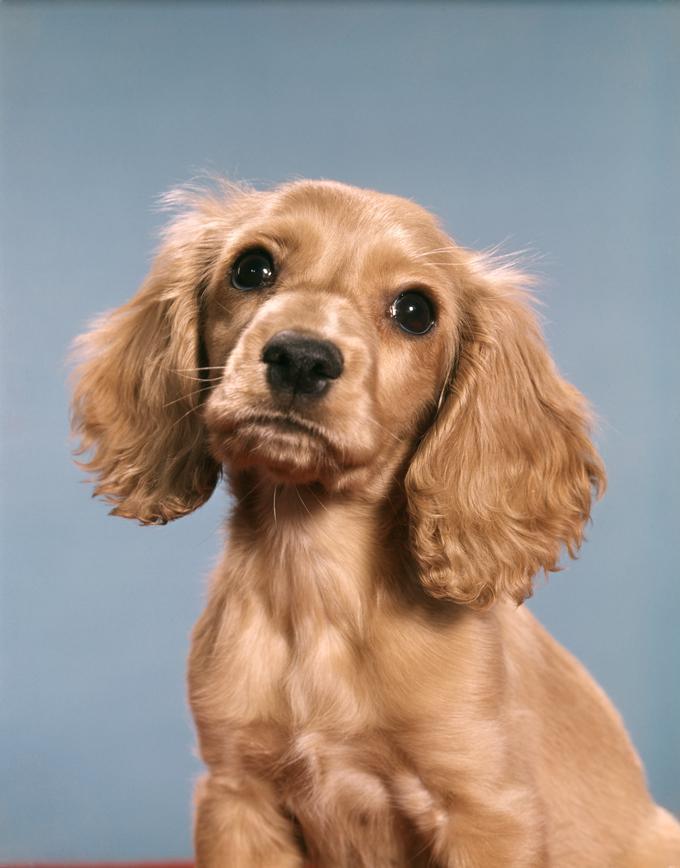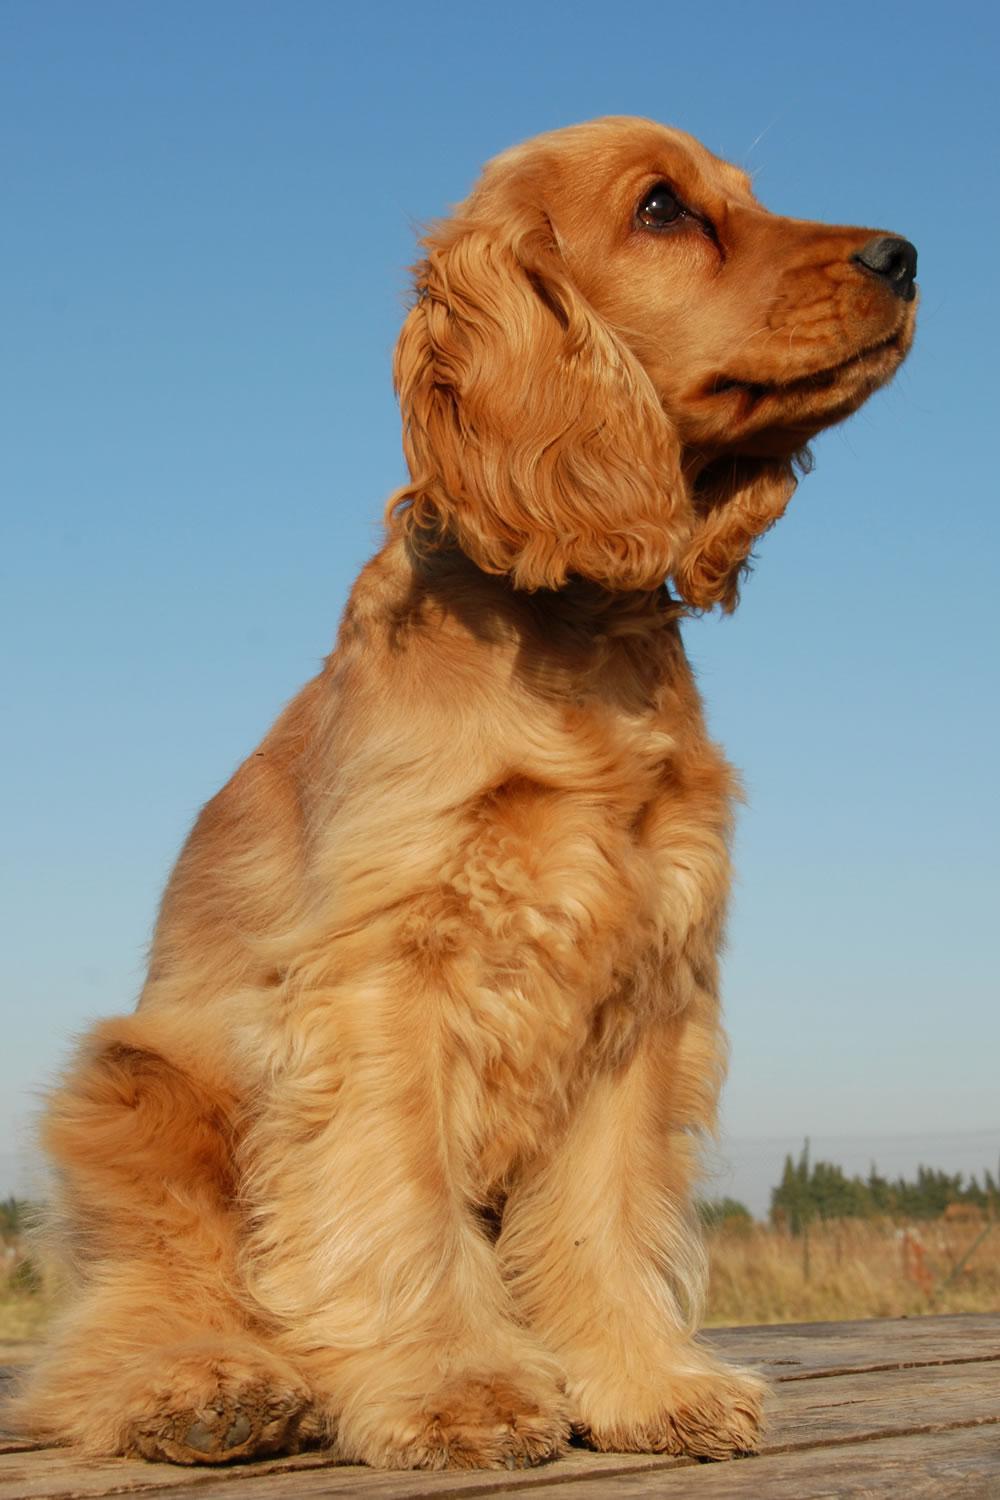The first image is the image on the left, the second image is the image on the right. Considering the images on both sides, is "The dog in the image on the left is lying on a grey material." valid? Answer yes or no. No. The first image is the image on the left, the second image is the image on the right. Given the left and right images, does the statement "An image shows one dog with its head resting on some type of grey soft surface." hold true? Answer yes or no. No. The first image is the image on the left, the second image is the image on the right. Given the left and right images, does the statement "the dog on the right image is facing right" hold true? Answer yes or no. Yes. The first image is the image on the left, the second image is the image on the right. For the images displayed, is the sentence "There is at least one dog indoors in the image on the left." factually correct? Answer yes or no. No. 